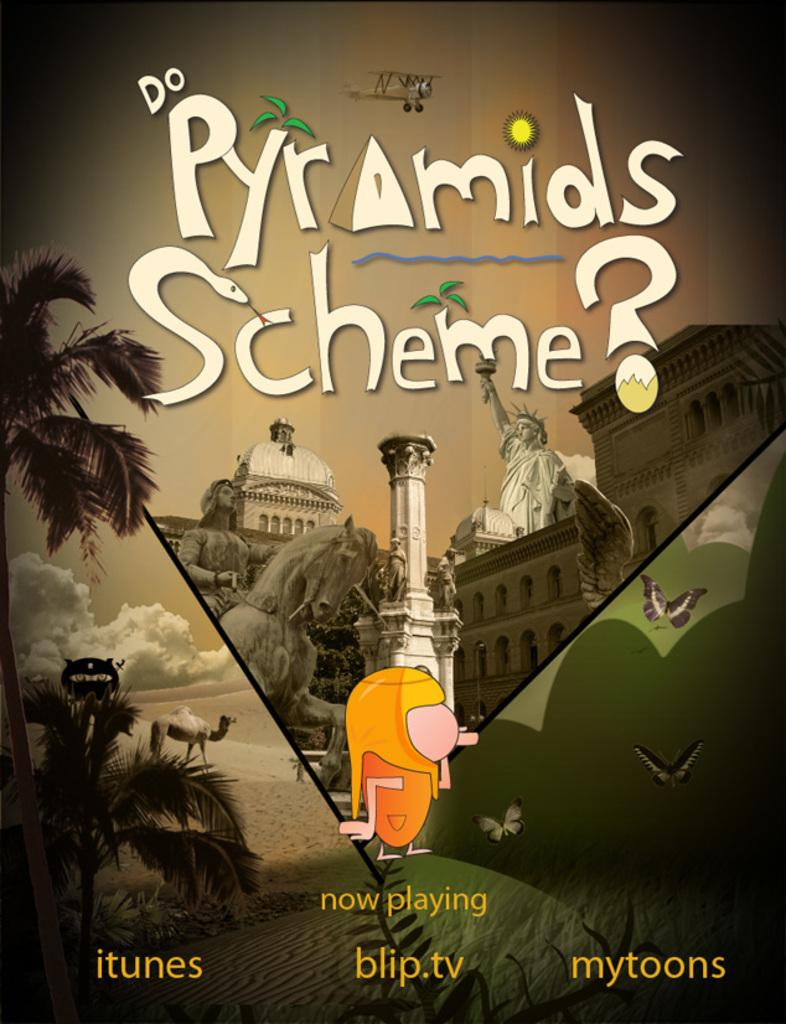What is featured in the image that has writing on it? There is a poster in the image that has something written on it. What type of structures can be seen in the image? There are buildings visible in the image. What living creatures are present in the image? There are birds in the image. What type of vegetation is visible in the image? There are trees in the image. What type of artistic objects can be seen in the image? There are statues in the image. What type of jar is being used by the person in the image? There is no person present in the image, and therefore no jar being used. 